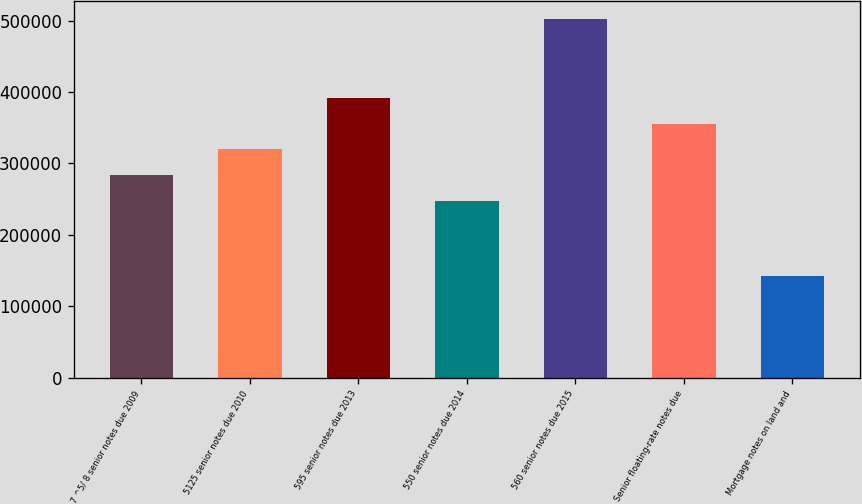<chart> <loc_0><loc_0><loc_500><loc_500><bar_chart><fcel>7 ^5/ 8 senior notes due 2009<fcel>5125 senior notes due 2010<fcel>595 senior notes due 2013<fcel>550 senior notes due 2014<fcel>560 senior notes due 2015<fcel>Senior floating-rate notes due<fcel>Mortgage notes on land and<nl><fcel>283597<fcel>319636<fcel>391712<fcel>247559<fcel>501957<fcel>355674<fcel>141574<nl></chart> 